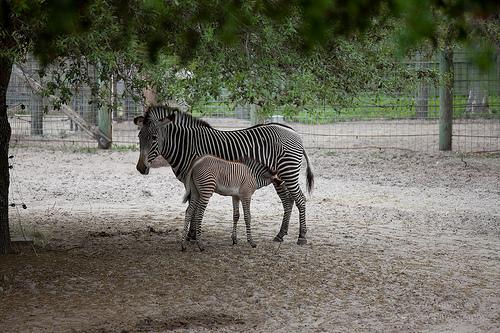Question: where is the picture taken?
Choices:
A. Car dealership.
B. Graduation.
C. Wedding.
D. In a zebra enclosure.
Answer with the letter. Answer: D Question: what animal is seen?
Choices:
A. Giraffe.
B. Zebra.
C. Elephant.
D. Dog.
Answer with the letter. Answer: B Question: what is the color of the zebra?
Choices:
A. Brown and gray.
B. Off-white and near-black.
C. There is no zebra.
D. Black and white.
Answer with the letter. Answer: D Question: what is the color of the leaves?
Choices:
A. Brown.
B. Red.
C. Orange.
D. Green.
Answer with the letter. Answer: D Question: what is the baby zebra doing?
Choices:
A. Eating grass.
B. Sleeping.
C. Running.
D. Drinking milk.
Answer with the letter. Answer: D Question: how many zebra?
Choices:
A. 4.
B. 3.
C. 5.
D. 2.
Answer with the letter. Answer: D 